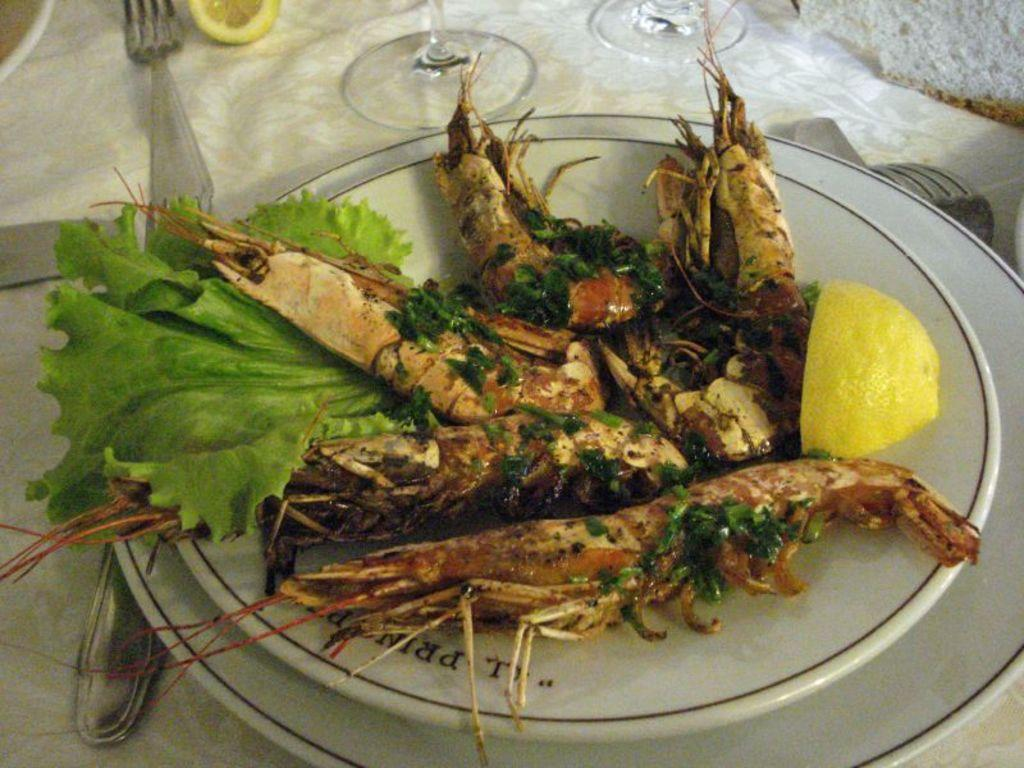What is on the plate that is visible in the image? There is a plate with shrimps, spinach, and a piece of lemon in the image. What utensils are visible in the image? There are forks visible in the image. What can be seen on the table in the image? There are glasses on the table in the image. What is the color of the tablecloth in the image? The cloth on the table appears to be white. What other items might be present on the table in the image? The table contains other items, but their specifics are not mentioned in the provided facts. How many horses are present in the image? There are no horses present in the image; it features a plate with shrimps, spinach, and a piece of lemon, along with forks, glasses, and a tablecloth. What type of toy can be seen playing with the shrimps in the image? There is no toy present in the image, and the shrimps are not being played with. 